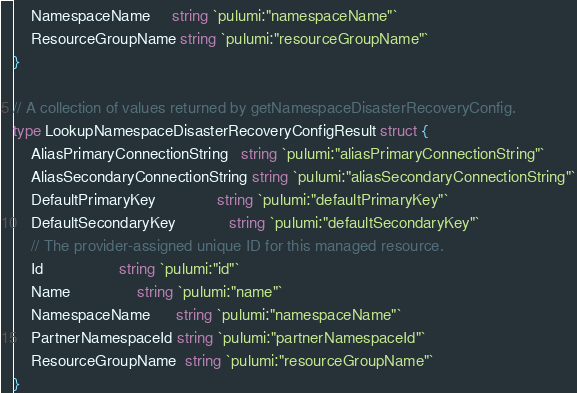Convert code to text. <code><loc_0><loc_0><loc_500><loc_500><_Go_>	NamespaceName     string `pulumi:"namespaceName"`
	ResourceGroupName string `pulumi:"resourceGroupName"`
}

// A collection of values returned by getNamespaceDisasterRecoveryConfig.
type LookupNamespaceDisasterRecoveryConfigResult struct {
	AliasPrimaryConnectionString   string `pulumi:"aliasPrimaryConnectionString"`
	AliasSecondaryConnectionString string `pulumi:"aliasSecondaryConnectionString"`
	DefaultPrimaryKey              string `pulumi:"defaultPrimaryKey"`
	DefaultSecondaryKey            string `pulumi:"defaultSecondaryKey"`
	// The provider-assigned unique ID for this managed resource.
	Id                 string `pulumi:"id"`
	Name               string `pulumi:"name"`
	NamespaceName      string `pulumi:"namespaceName"`
	PartnerNamespaceId string `pulumi:"partnerNamespaceId"`
	ResourceGroupName  string `pulumi:"resourceGroupName"`
}
</code> 